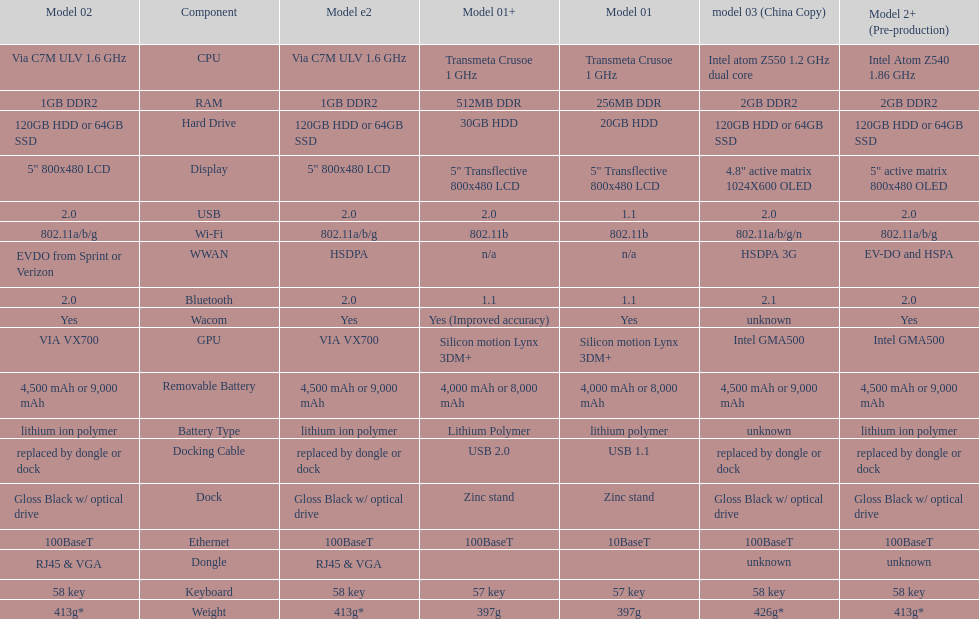The model 2 and the model 2e have what type of cpu? Via C7M ULV 1.6 GHz. Would you be able to parse every entry in this table? {'header': ['Model 02', 'Component', 'Model e2', 'Model 01+', 'Model 01', 'model 03 (China Copy)', 'Model 2+ (Pre-production)'], 'rows': [['Via C7M ULV 1.6\xa0GHz', 'CPU', 'Via C7M ULV 1.6\xa0GHz', 'Transmeta Crusoe 1\xa0GHz', 'Transmeta Crusoe 1\xa0GHz', 'Intel atom Z550 1.2\xa0GHz dual core', 'Intel Atom Z540 1.86\xa0GHz'], ['1GB DDR2', 'RAM', '1GB DDR2', '512MB DDR', '256MB DDR', '2GB DDR2', '2GB DDR2'], ['120GB HDD or 64GB SSD', 'Hard Drive', '120GB HDD or 64GB SSD', '30GB HDD', '20GB HDD', '120GB HDD or 64GB SSD', '120GB HDD or 64GB SSD'], ['5" 800x480 LCD', 'Display', '5" 800x480 LCD', '5" Transflective 800x480 LCD', '5" Transflective 800x480 LCD', '4.8" active matrix 1024X600 OLED', '5" active matrix 800x480 OLED'], ['2.0', 'USB', '2.0', '2.0', '1.1', '2.0', '2.0'], ['802.11a/b/g', 'Wi-Fi', '802.11a/b/g', '802.11b', '802.11b', '802.11a/b/g/n', '802.11a/b/g'], ['EVDO from Sprint or Verizon', 'WWAN', 'HSDPA', 'n/a', 'n/a', 'HSDPA 3G', 'EV-DO and HSPA'], ['2.0', 'Bluetooth', '2.0', '1.1', '1.1', '2.1', '2.0'], ['Yes', 'Wacom', 'Yes', 'Yes (Improved accuracy)', 'Yes', 'unknown', 'Yes'], ['VIA VX700', 'GPU', 'VIA VX700', 'Silicon motion Lynx 3DM+', 'Silicon motion Lynx 3DM+', 'Intel GMA500', 'Intel GMA500'], ['4,500 mAh or 9,000 mAh', 'Removable Battery', '4,500 mAh or 9,000 mAh', '4,000 mAh or 8,000 mAh', '4,000 mAh or 8,000 mAh', '4,500 mAh or 9,000 mAh', '4,500 mAh or 9,000 mAh'], ['lithium ion polymer', 'Battery Type', 'lithium ion polymer', 'Lithium Polymer', 'lithium polymer', 'unknown', 'lithium ion polymer'], ['replaced by dongle or dock', 'Docking Cable', 'replaced by dongle or dock', 'USB 2.0', 'USB 1.1', 'replaced by dongle or dock', 'replaced by dongle or dock'], ['Gloss Black w/ optical drive', 'Dock', 'Gloss Black w/ optical drive', 'Zinc stand', 'Zinc stand', 'Gloss Black w/ optical drive', 'Gloss Black w/ optical drive'], ['100BaseT', 'Ethernet', '100BaseT', '100BaseT', '10BaseT', '100BaseT', '100BaseT'], ['RJ45 & VGA', 'Dongle', 'RJ45 & VGA', '', '', 'unknown', 'unknown'], ['58 key', 'Keyboard', '58 key', '57 key', '57 key', '58 key', '58 key'], ['413g*', 'Weight', '413g*', '397g', '397g', '426g*', '413g*']]} 